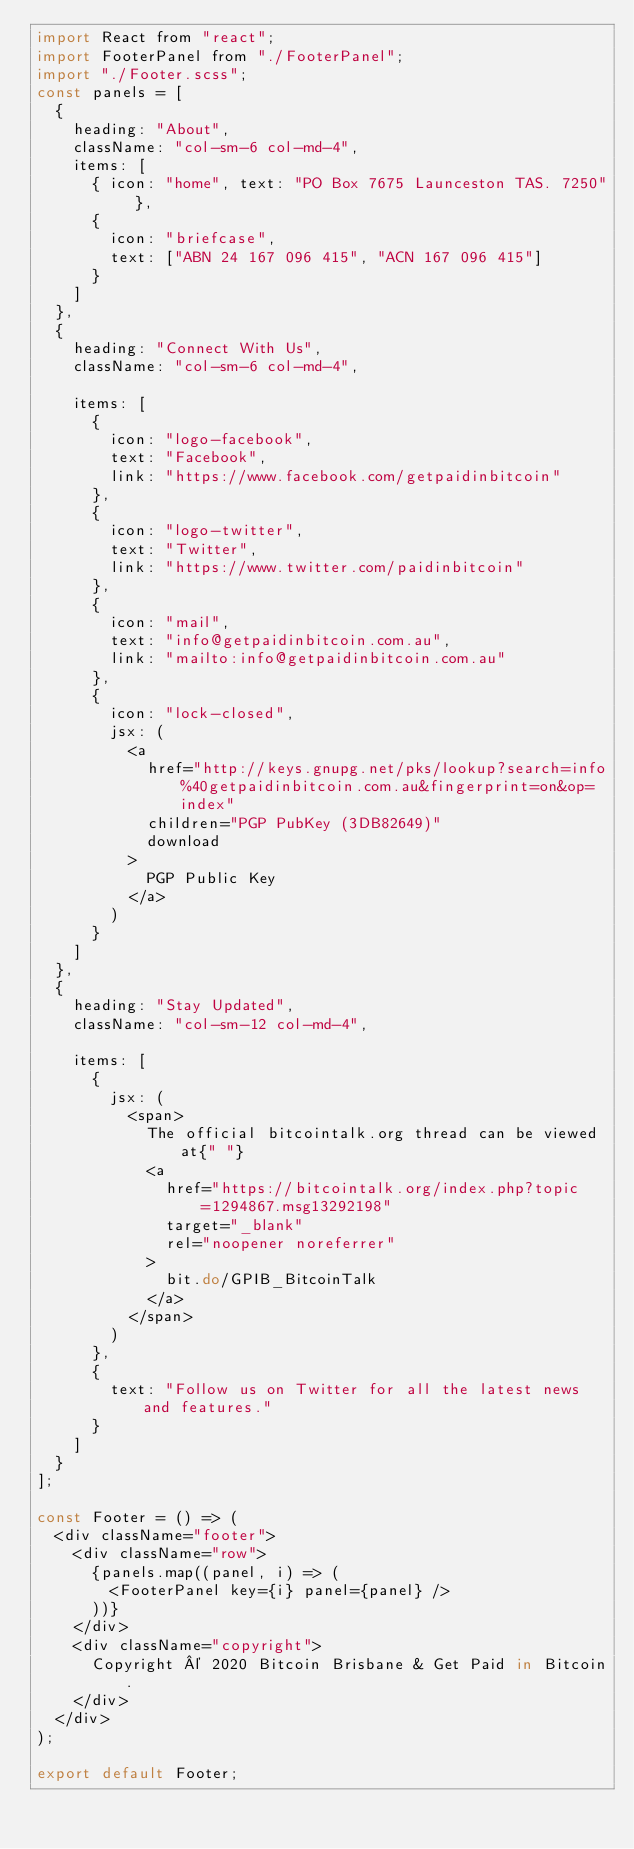Convert code to text. <code><loc_0><loc_0><loc_500><loc_500><_JavaScript_>import React from "react";
import FooterPanel from "./FooterPanel";
import "./Footer.scss";
const panels = [
  {
    heading: "About",
    className: "col-sm-6 col-md-4",
    items: [
      { icon: "home", text: "PO Box 7675 Launceston TAS. 7250" },
      {
        icon: "briefcase",
        text: ["ABN 24 167 096 415", "ACN 167 096 415"]
      }
    ]
  },
  {
    heading: "Connect With Us",
    className: "col-sm-6 col-md-4",

    items: [
      {
        icon: "logo-facebook",
        text: "Facebook",
        link: "https://www.facebook.com/getpaidinbitcoin"
      },
      {
        icon: "logo-twitter",
        text: "Twitter",
        link: "https://www.twitter.com/paidinbitcoin"
      },
      {
        icon: "mail",
        text: "info@getpaidinbitcoin.com.au",
        link: "mailto:info@getpaidinbitcoin.com.au"
      },
      {
        icon: "lock-closed",
        jsx: (
          <a
            href="http://keys.gnupg.net/pks/lookup?search=info%40getpaidinbitcoin.com.au&fingerprint=on&op=index"
            children="PGP PubKey (3DB82649)"
            download
          >
            PGP Public Key
          </a>
        )
      }
    ]
  },
  {
    heading: "Stay Updated",
    className: "col-sm-12 col-md-4",

    items: [
      {
        jsx: (
          <span>
            The official bitcointalk.org thread can be viewed at{" "}
            <a
              href="https://bitcointalk.org/index.php?topic=1294867.msg13292198"
              target="_blank"
              rel="noopener noreferrer"
            >
              bit.do/GPIB_BitcoinTalk
            </a>
          </span>
        )
      },
      {
        text: "Follow us on Twitter for all the latest news and features."
      }
    ]
  }
];

const Footer = () => (
  <div className="footer">
    <div className="row">
      {panels.map((panel, i) => (
        <FooterPanel key={i} panel={panel} />
      ))}
    </div>
    <div className="copyright">
      Copyright © 2020 Bitcoin Brisbane & Get Paid in Bitcoin.
    </div>
  </div>
);

export default Footer;
</code> 